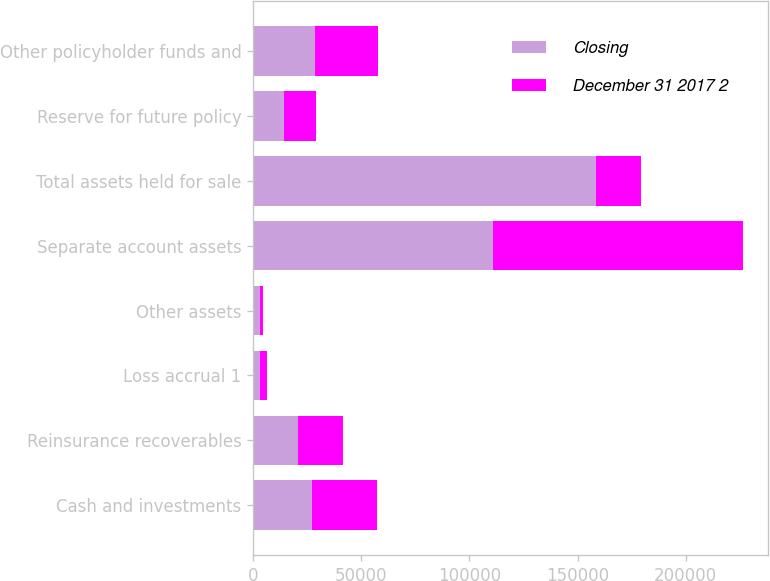Convert chart to OTSL. <chart><loc_0><loc_0><loc_500><loc_500><stacked_bar_chart><ecel><fcel>Cash and investments<fcel>Reinsurance recoverables<fcel>Loss accrual 1<fcel>Other assets<fcel>Separate account assets<fcel>Total assets held for sale<fcel>Reserve for future policy<fcel>Other policyholder funds and<nl><fcel>Closing<fcel>27058<fcel>20718<fcel>3044<fcel>2907<fcel>110773<fcel>158412<fcel>14308<fcel>28680<nl><fcel>December 31 2017 2<fcel>30135<fcel>20785<fcel>3257<fcel>1439<fcel>115834<fcel>20785<fcel>14482<fcel>29228<nl></chart> 